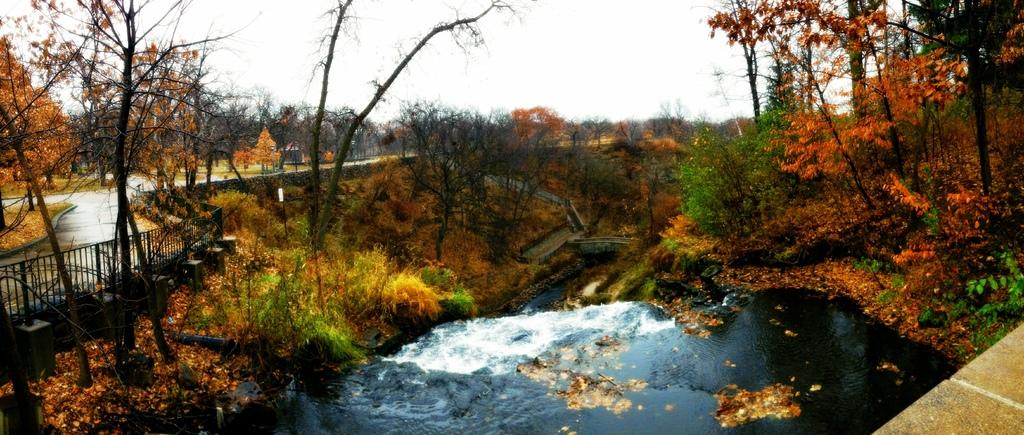What type of natural elements can be seen in the image? There are trees and a waterfall in the image. What man-made structure is present in the image? There is a road in the image. Is there any safety feature associated with the road? Yes, there is a railing next to the road. What can be seen in the background of the image? The sky is visible in the background of the image. How many rabbits can be seen hopping along the road in the image? There are no rabbits present in the image. What type of liquid is flowing from the waterfall in the image? The image does not provide enough information to determine the type of liquid flowing from the waterfall. 